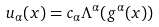Convert formula to latex. <formula><loc_0><loc_0><loc_500><loc_500>u _ { \alpha } ( x ) = c _ { \alpha } \Lambda ^ { \alpha } ( g ^ { \alpha } ( x ) )</formula> 